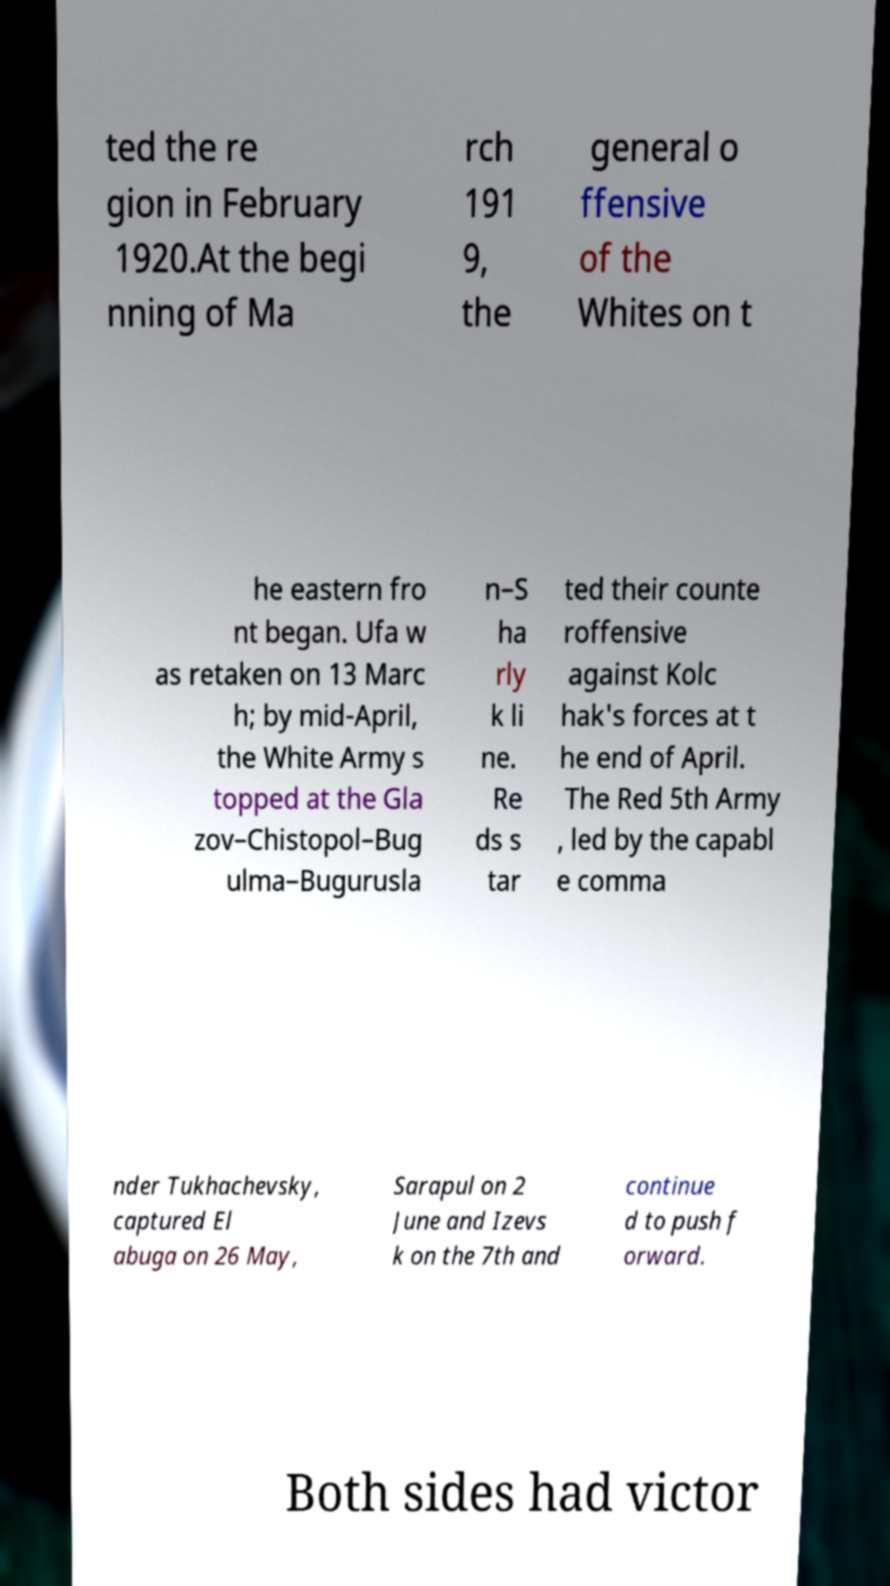What messages or text are displayed in this image? I need them in a readable, typed format. ted the re gion in February 1920.At the begi nning of Ma rch 191 9, the general o ffensive of the Whites on t he eastern fro nt began. Ufa w as retaken on 13 Marc h; by mid-April, the White Army s topped at the Gla zov–Chistopol–Bug ulma–Bugurusla n–S ha rly k li ne. Re ds s tar ted their counte roffensive against Kolc hak's forces at t he end of April. The Red 5th Army , led by the capabl e comma nder Tukhachevsky, captured El abuga on 26 May, Sarapul on 2 June and Izevs k on the 7th and continue d to push f orward. Both sides had victor 